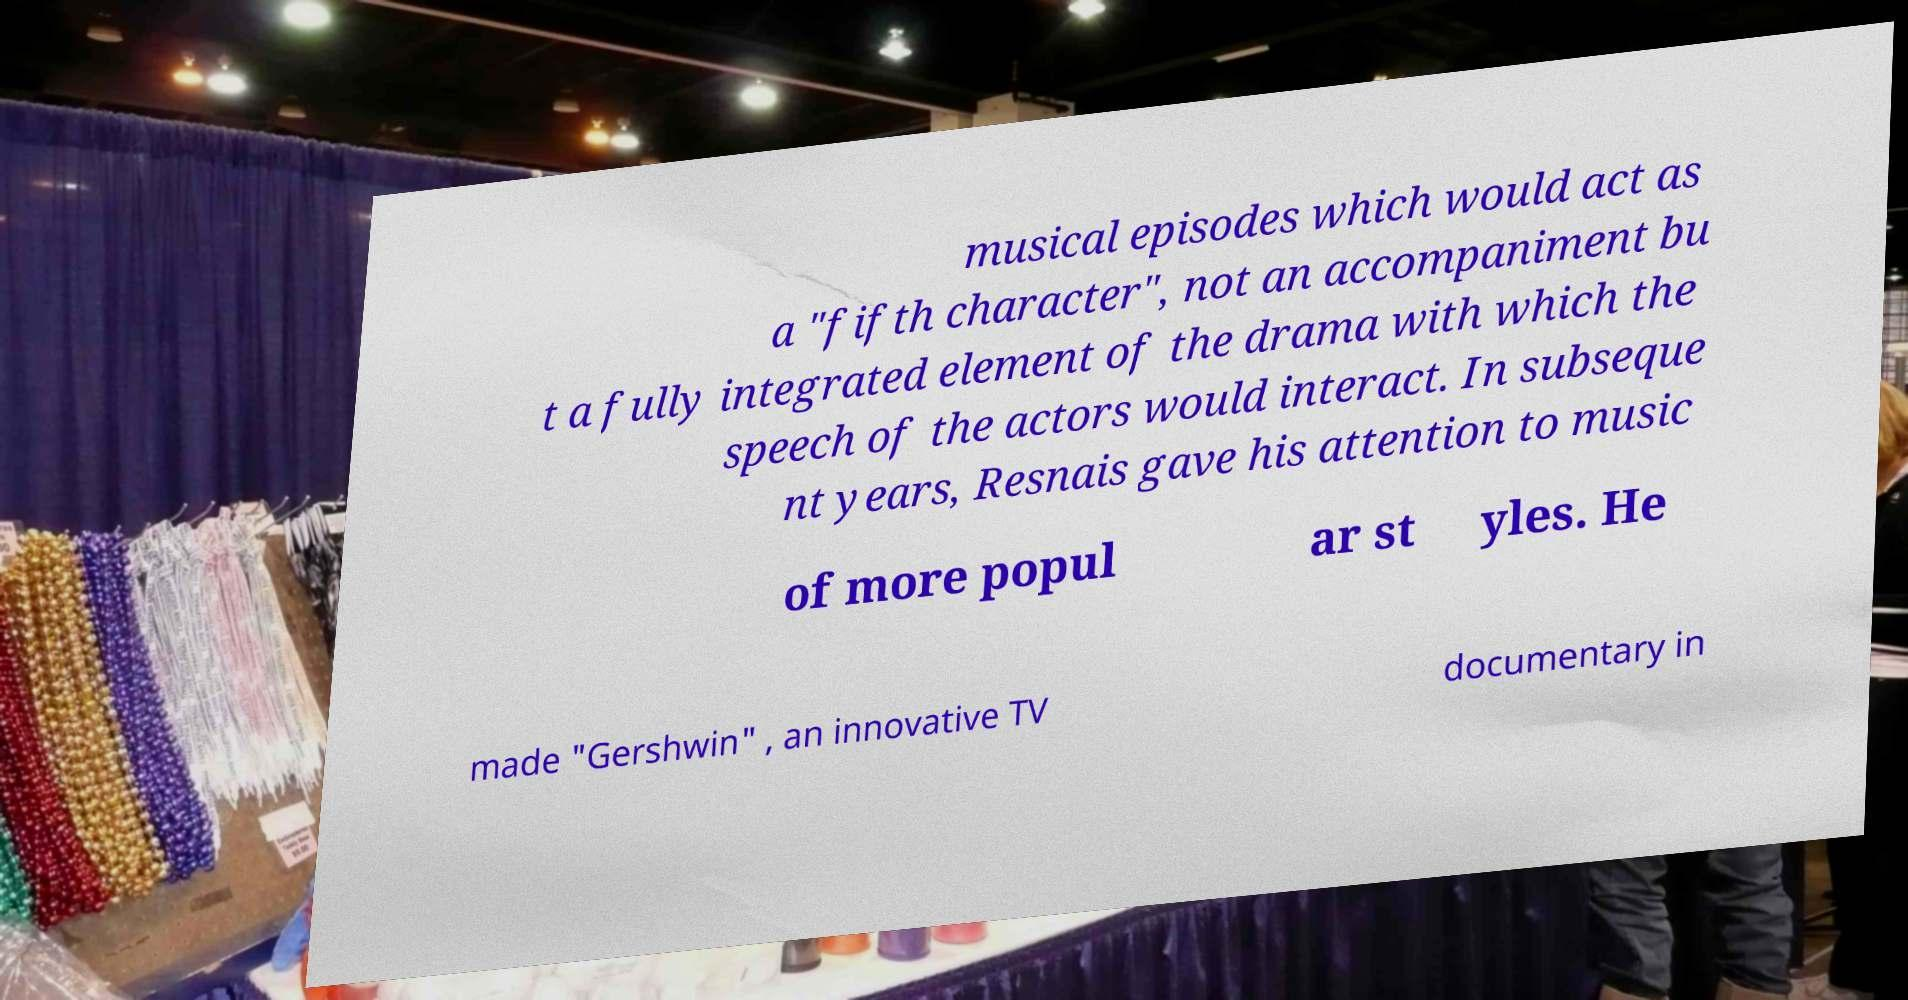Please identify and transcribe the text found in this image. musical episodes which would act as a "fifth character", not an accompaniment bu t a fully integrated element of the drama with which the speech of the actors would interact. In subseque nt years, Resnais gave his attention to music of more popul ar st yles. He made "Gershwin" , an innovative TV documentary in 